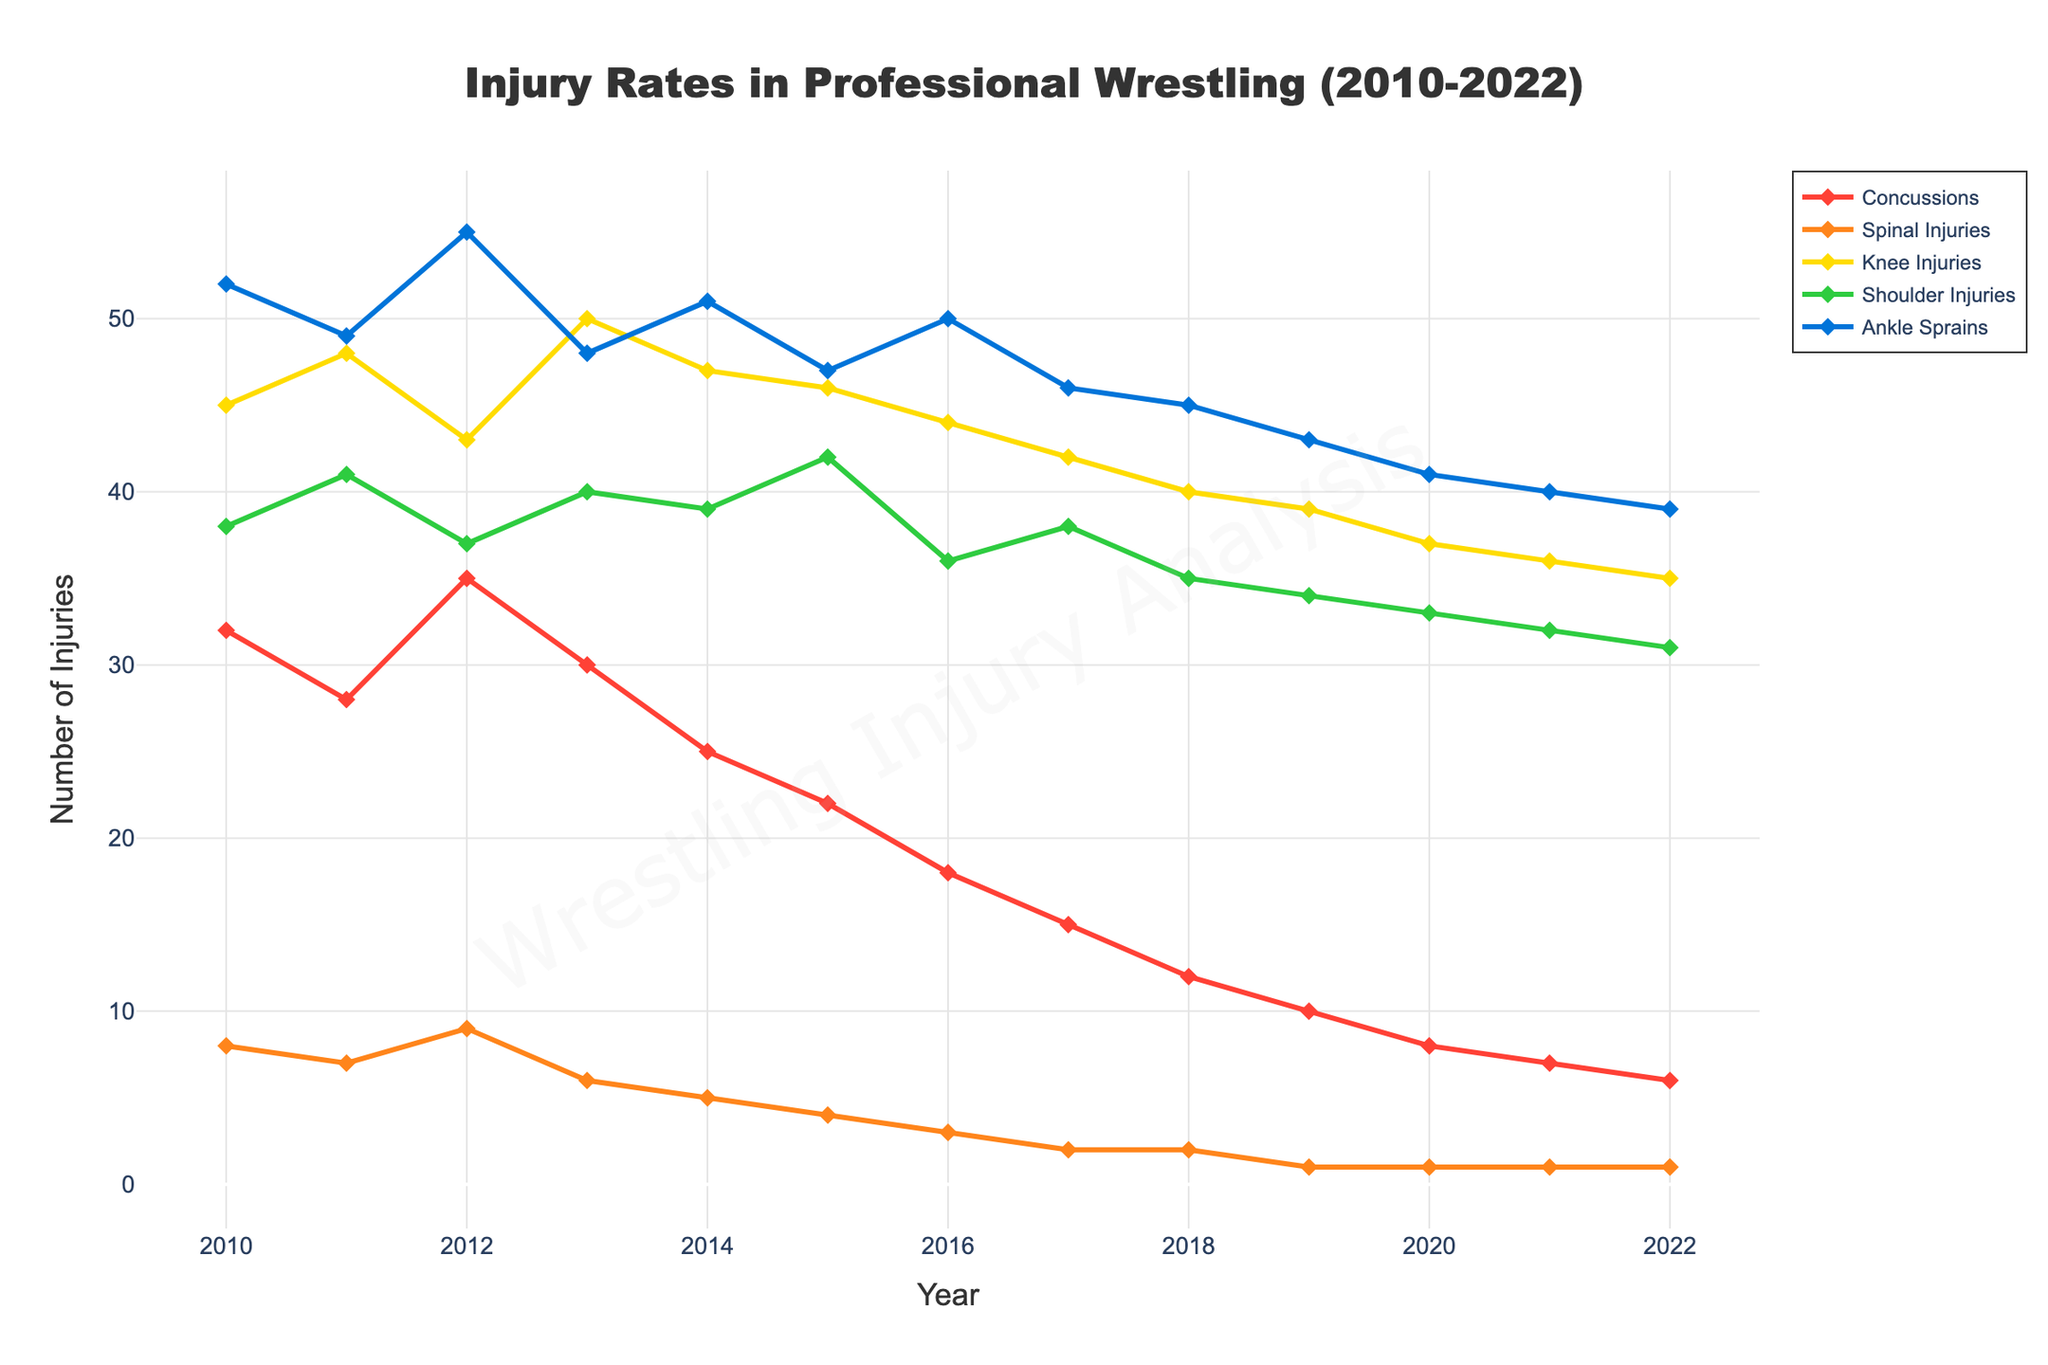What type of injury saw the highest rate in 2010? According to the figure, the injury type with the highest rate in 2010 is indicated by the highest line marker among the different types. The Ankle Sprains trace is the highest.
Answer: Ankle Sprains What is the overall trend of concussions from 2010 to 2022? To determine the trend, observe the line for concussions from 2010 to 2022. The line consistently decreases over the years.
Answer: Decreasing Which year had the lowest number of spinal injuries? By identifying the lowest point on the line representing spinal injuries, we see the lowest point in 2019, 2020, 2021, and 2022.
Answer: 2019, 2020, 2021, 2022 Compare the number of knee injuries between 2013 and 2022. Which year had higher injuries? Compare the height of the line markers for knee injuries in 2013 and 2022. The point for 2013 is higher than that of 2022.
Answer: 2013 Did shoulder injuries increase or decrease from 2012 to 2015? Look at the line for shoulder injuries between 2012 and 2015. The line moves upward, indicating an increase in injuries.
Answer: Increase What is the difference in the number of concussions between 2010 and 2022? Subtract the number of concussions in 2022 from that in 2010. The difference is 32 - 6 = 26.
Answer: 26 Which injury type had the least fluctuation in the number of injuries over the years? Examine the injury types to identify which line remains most consistent across years. Spinal Injuries show the most consistent pattern with less fluctuation.
Answer: Spinal Injuries How many years did concussions have more than 30 injuries? Identify the years where the line for concussions exceeds the 30 injury mark. These years are 2010, 2012, and 2013.
Answer: 3 What is the average number of ankle sprains from 2010 to 2022? Sum all the numbers for ankle sprains and divide by the number of years (13). The calculation is (52+49+55+48+51+47+50+46+45+43+41+40+39) / 13 ≈ 46.3.
Answer: 46.3 